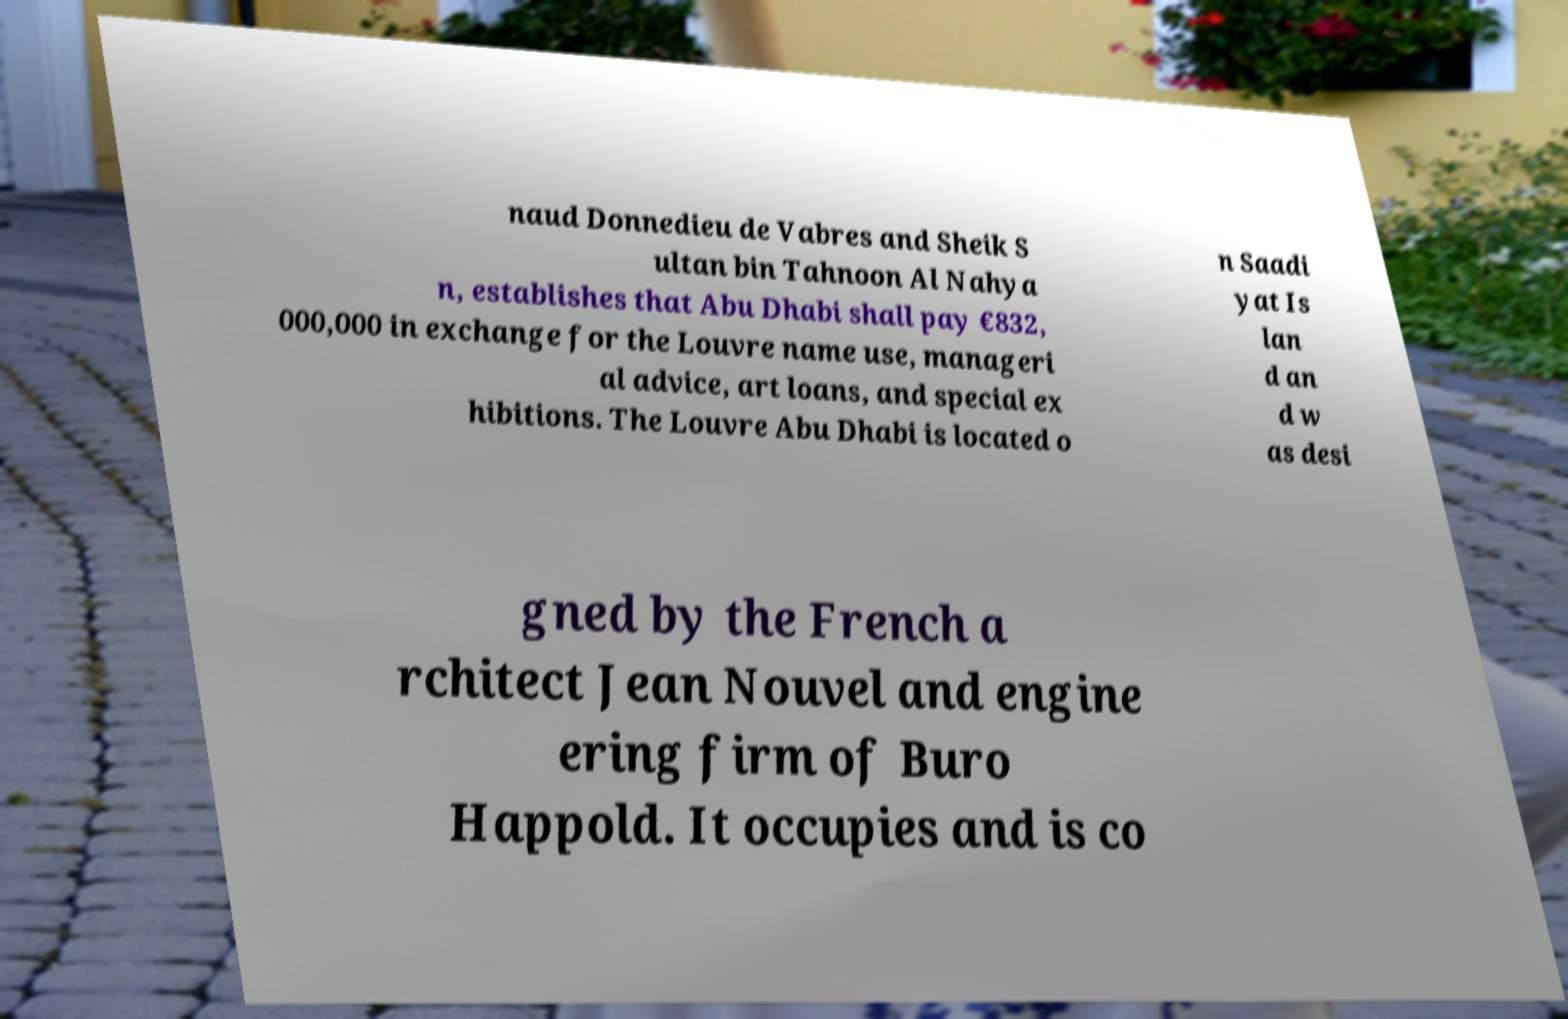Could you assist in decoding the text presented in this image and type it out clearly? naud Donnedieu de Vabres and Sheik S ultan bin Tahnoon Al Nahya n, establishes that Abu Dhabi shall pay €832, 000,000 in exchange for the Louvre name use, manageri al advice, art loans, and special ex hibitions. The Louvre Abu Dhabi is located o n Saadi yat Is lan d an d w as desi gned by the French a rchitect Jean Nouvel and engine ering firm of Buro Happold. It occupies and is co 